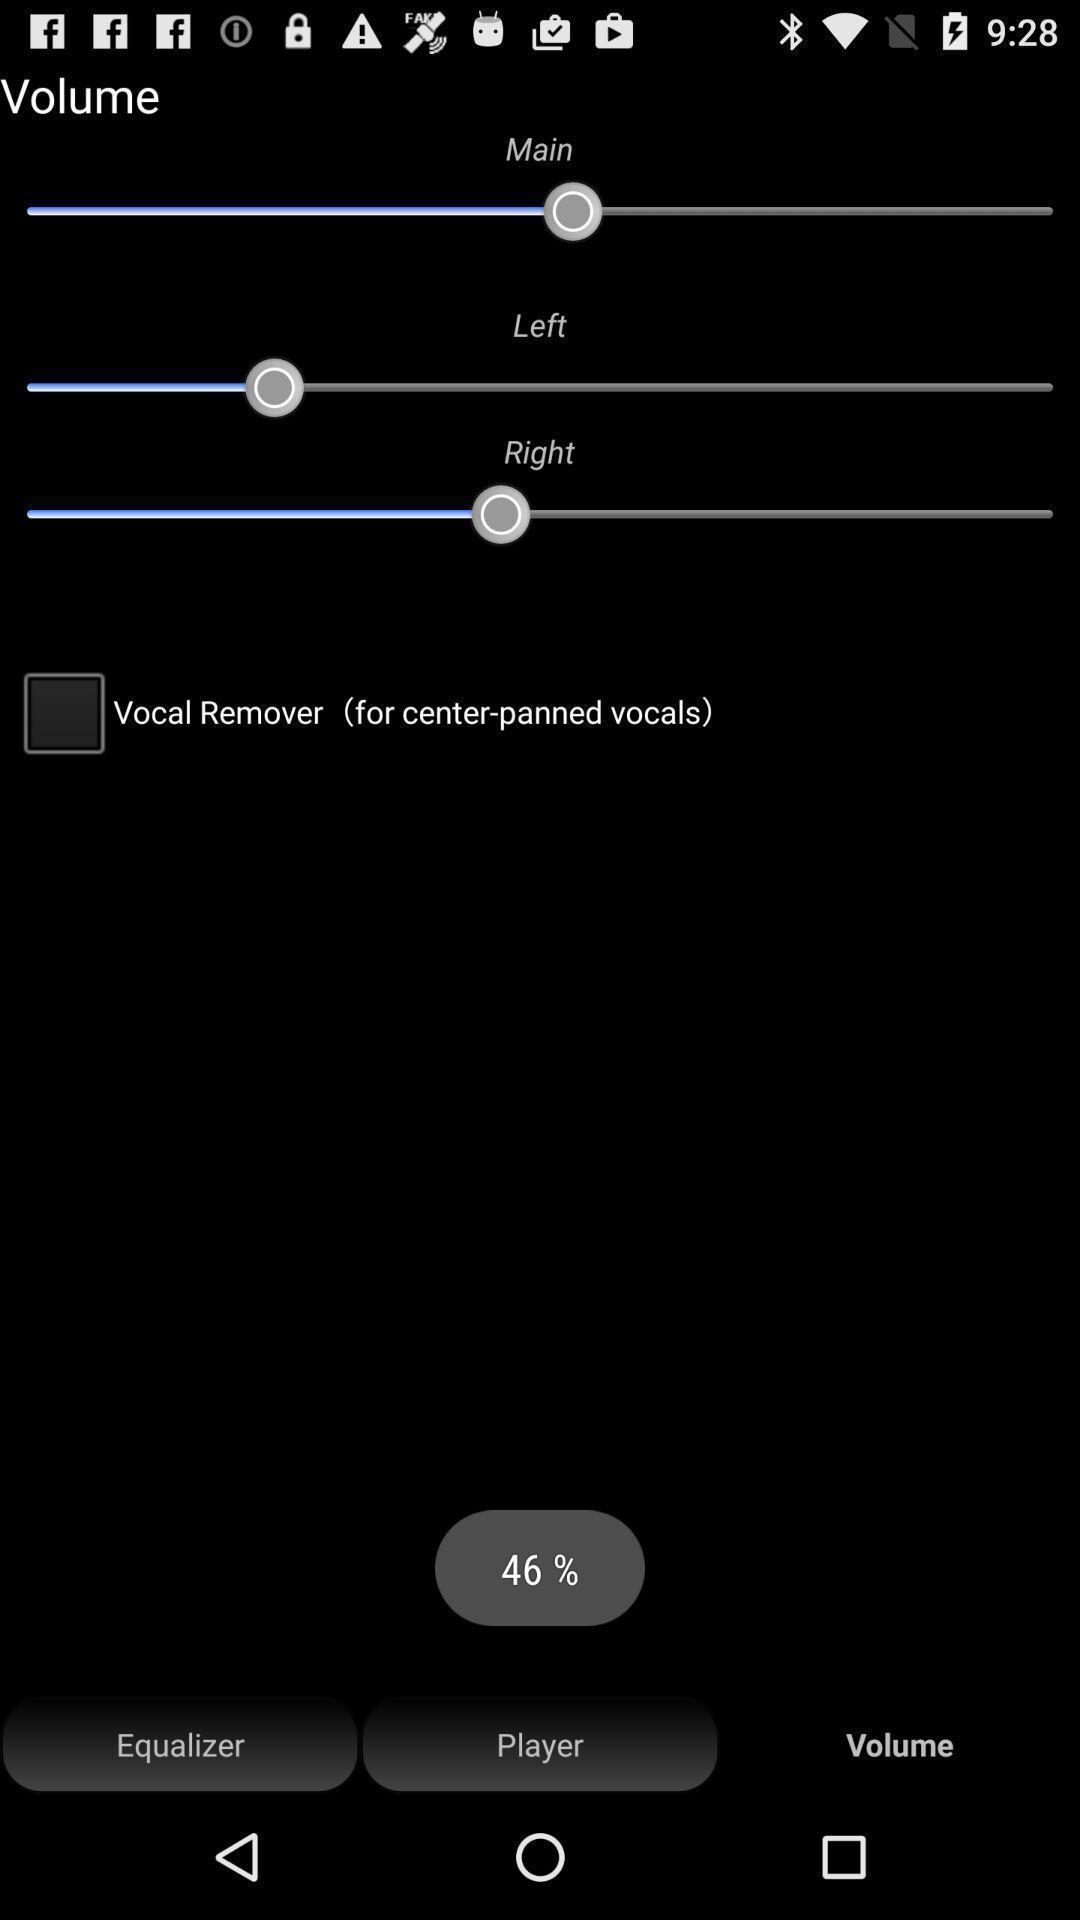Give me a narrative description of this picture. Sound mix options displayed of an audio app. 